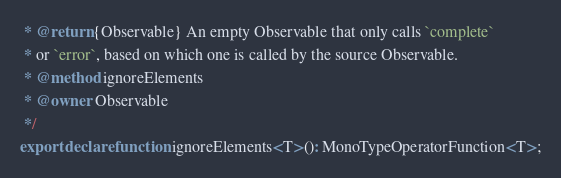<code> <loc_0><loc_0><loc_500><loc_500><_TypeScript_> * @return {Observable} An empty Observable that only calls `complete`
 * or `error`, based on which one is called by the source Observable.
 * @method ignoreElements
 * @owner Observable
 */
export declare function ignoreElements<T>(): MonoTypeOperatorFunction<T>;
</code> 